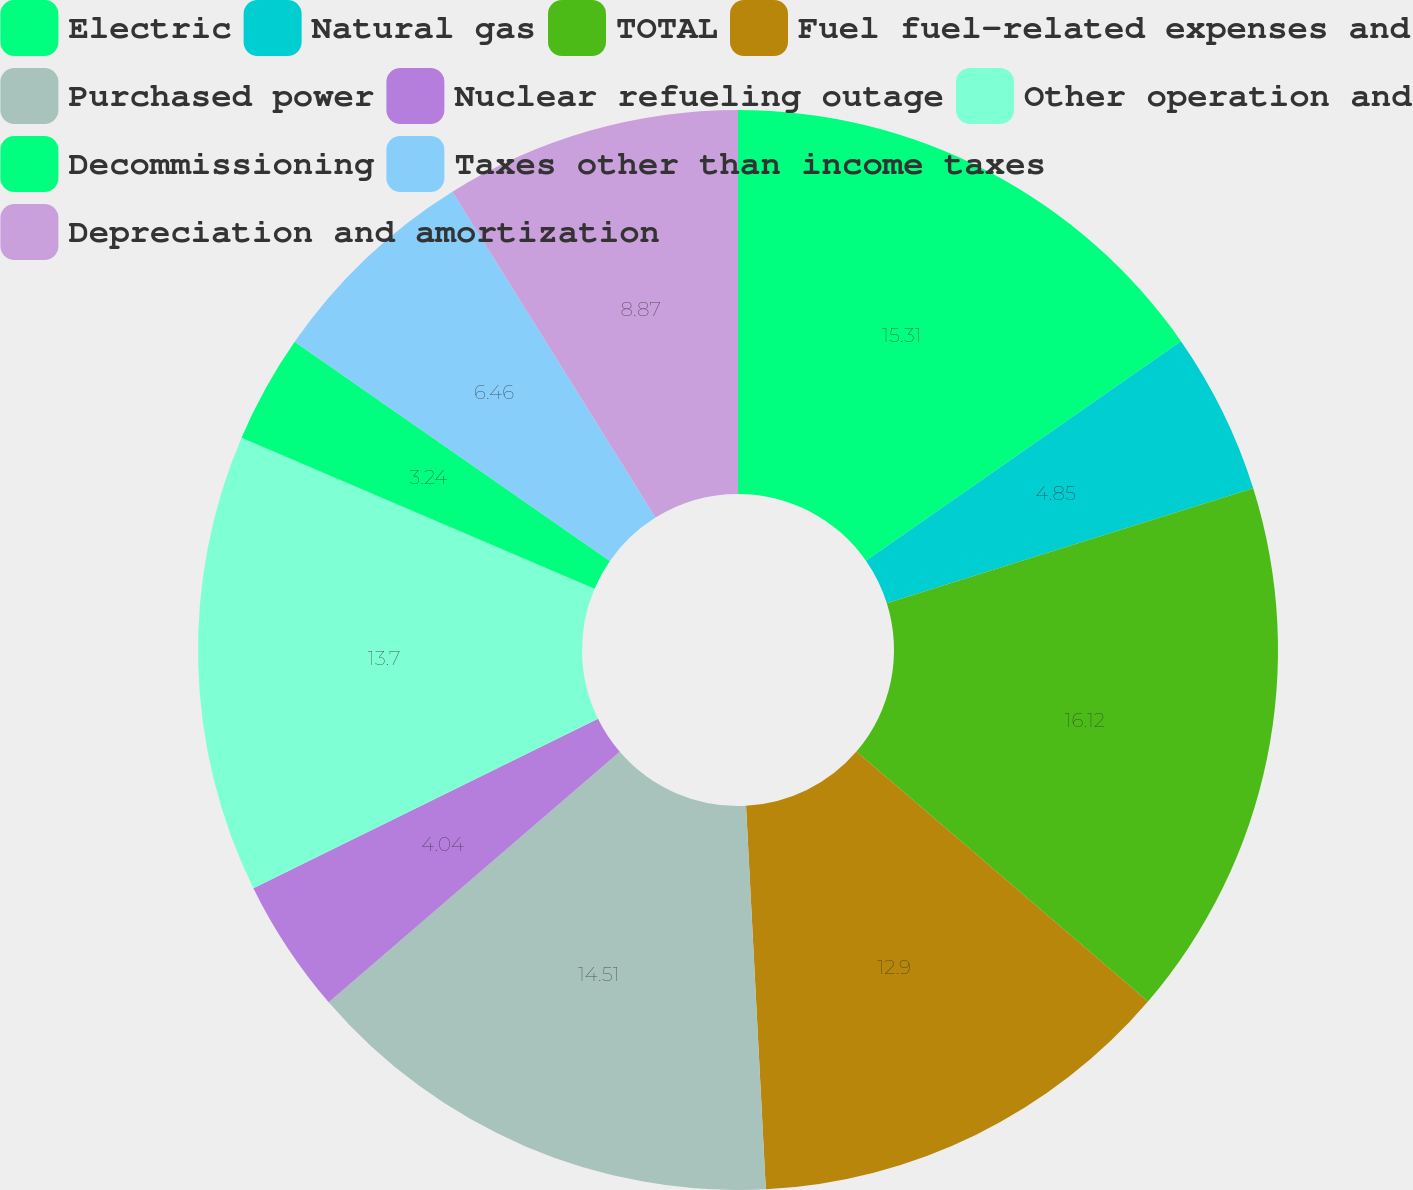Convert chart. <chart><loc_0><loc_0><loc_500><loc_500><pie_chart><fcel>Electric<fcel>Natural gas<fcel>TOTAL<fcel>Fuel fuel-related expenses and<fcel>Purchased power<fcel>Nuclear refueling outage<fcel>Other operation and<fcel>Decommissioning<fcel>Taxes other than income taxes<fcel>Depreciation and amortization<nl><fcel>15.31%<fcel>4.85%<fcel>16.12%<fcel>12.9%<fcel>14.51%<fcel>4.04%<fcel>13.7%<fcel>3.24%<fcel>6.46%<fcel>8.87%<nl></chart> 